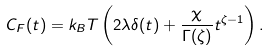<formula> <loc_0><loc_0><loc_500><loc_500>C _ { F } ( t ) = k _ { B } T \left ( 2 \lambda \delta ( t ) + \frac { \chi } { \Gamma ( \zeta ) } t ^ { \zeta - 1 } \right ) .</formula> 